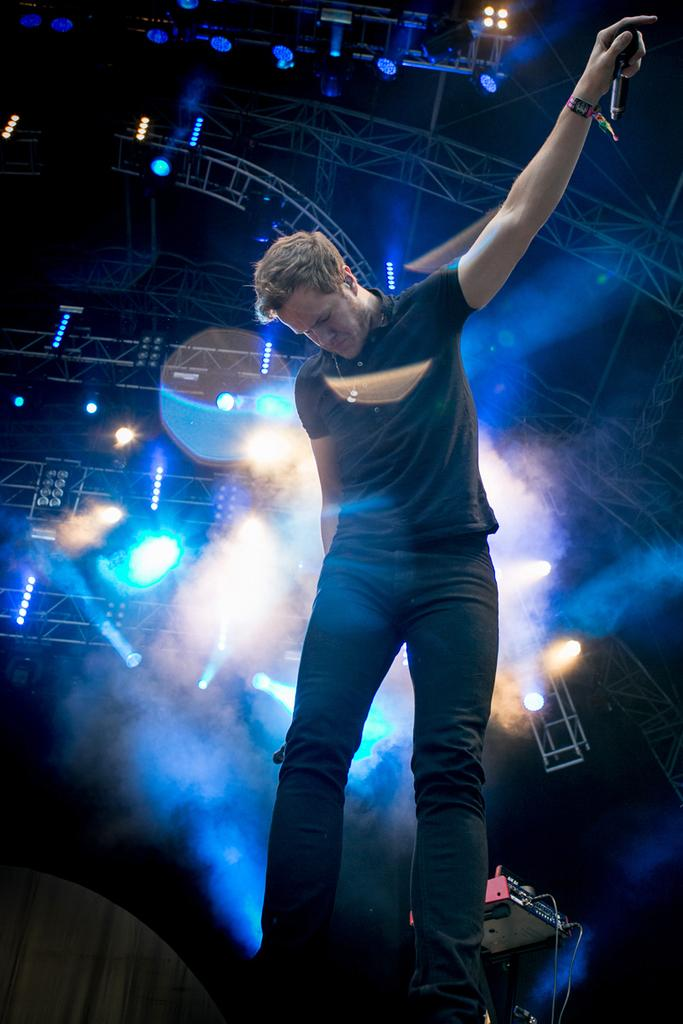What is the person in the image doing? The person is standing in the image and holding a mic in his hands. What can be seen in the background of the image? There are musical instruments, electric lights, and grills in the background of the image. How many fingers does the boy have on his left hand in the image? There is no boy present in the image, and therefore no information about the number of fingers on his left hand can be provided. 